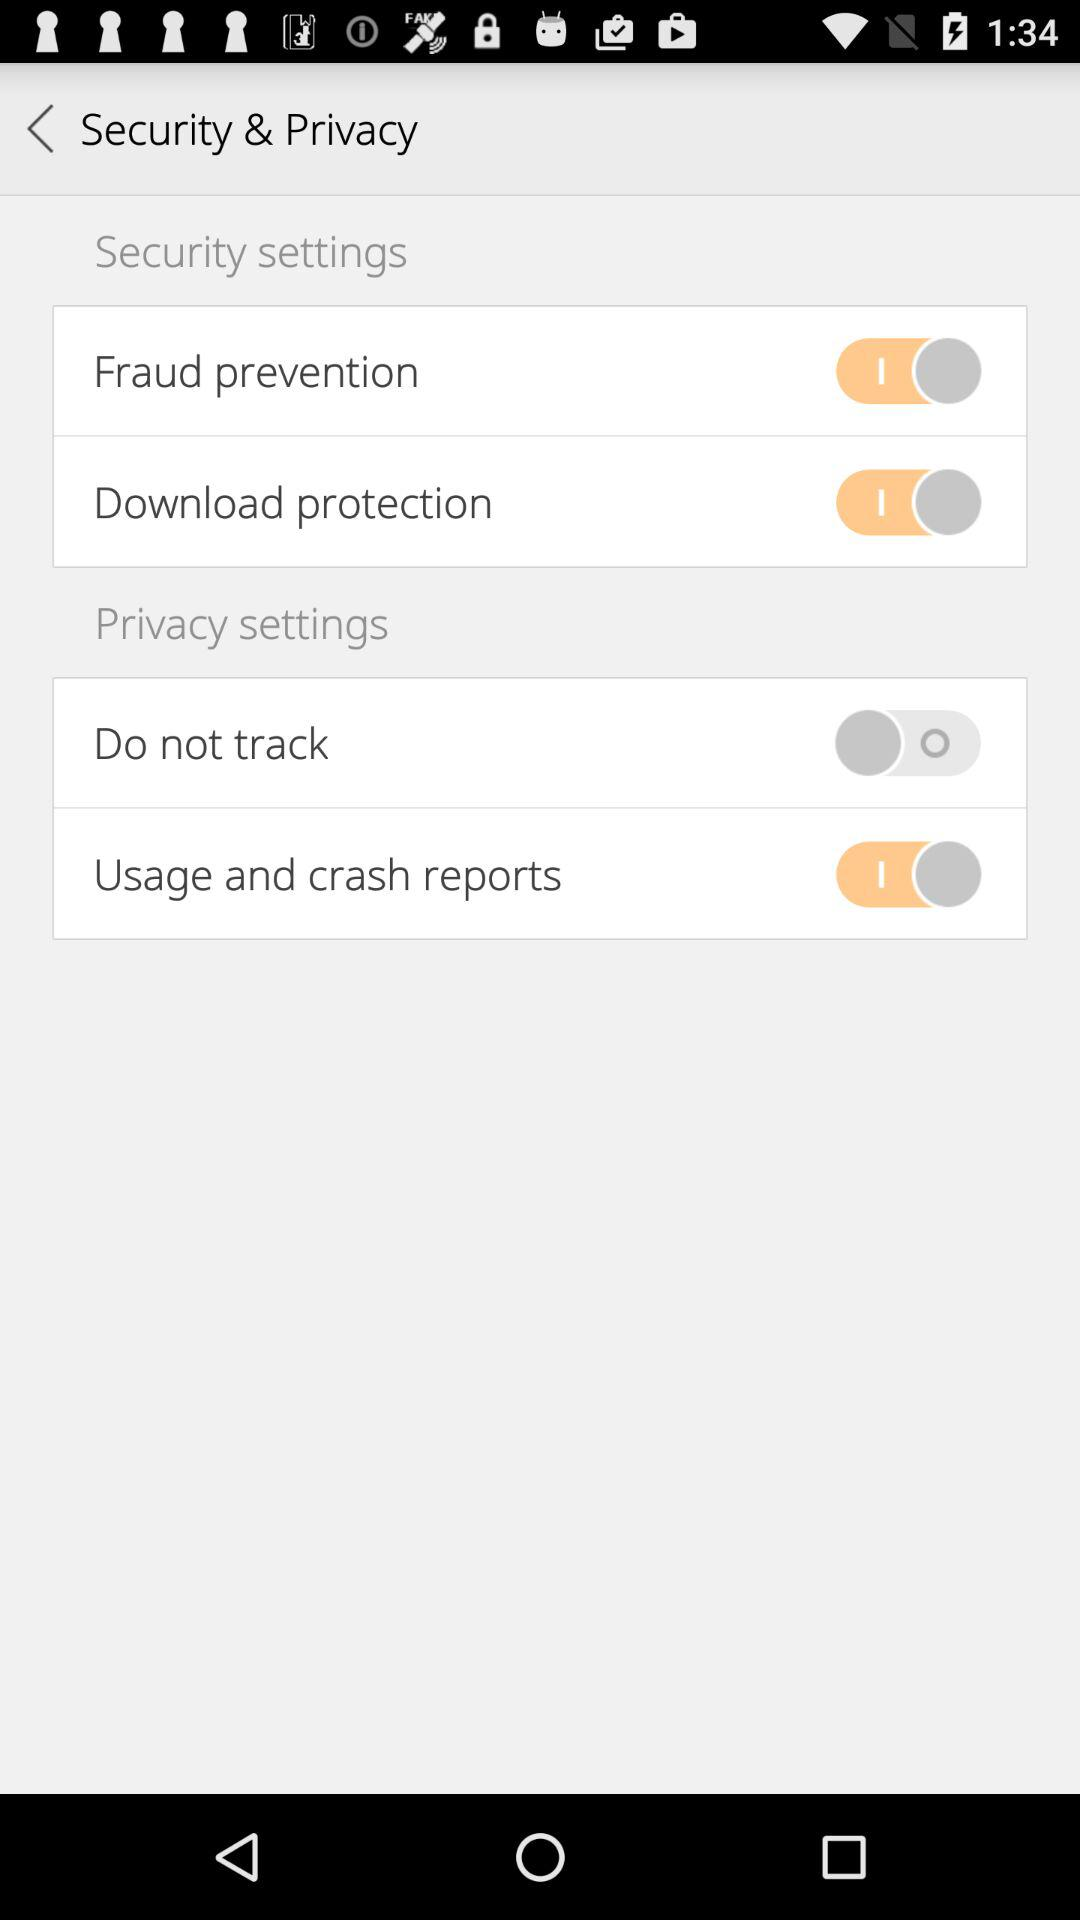What is the status of "Fraud prevention"? The status is "on". 